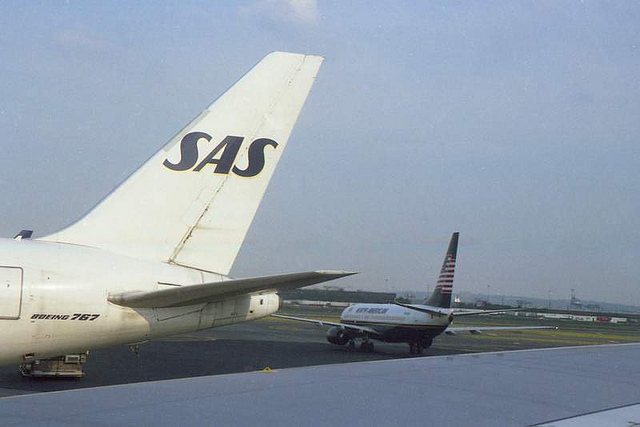Identify and read out the text in this image. SAS 767 